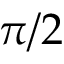<formula> <loc_0><loc_0><loc_500><loc_500>\pi / 2</formula> 